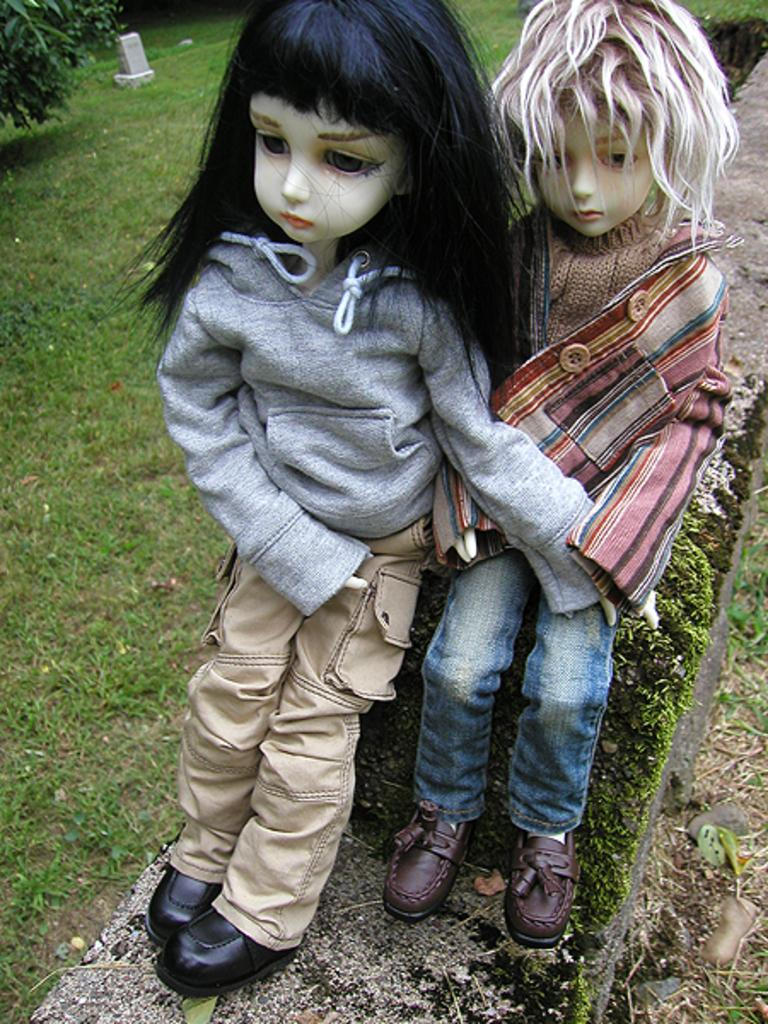How many dolls are present in the image? There are two dolls in the image. What type of natural environment is visible in the image? There is grass visible in the image. What can be seen on the left side of the image? There are leaves on the left side of the image. What type of jail is depicted in the image? There is no jail present in the image. Who is the father of the dolls in the image? The image does not provide information about the dolls' parents, so it cannot be determined who their father is. 